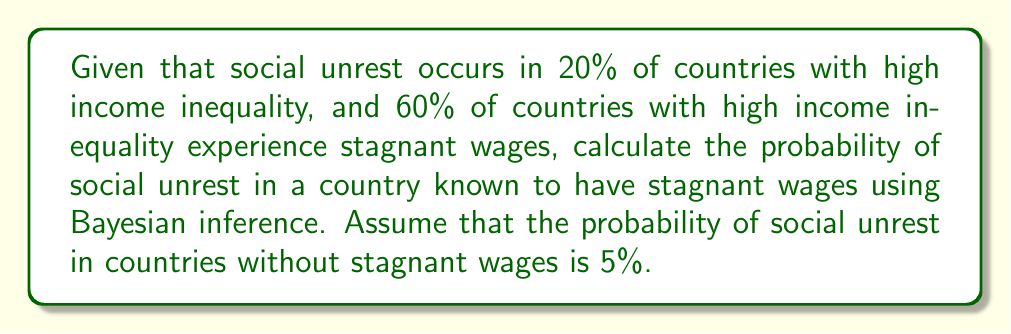Could you help me with this problem? Let's approach this step-by-step using Bayesian inference:

1) Define our events:
   A: Social unrest occurs
   B: Country has stagnant wages

2) Given probabilities:
   P(A) = 0.20 (probability of social unrest in countries with high income inequality)
   P(B) = 0.60 (probability of stagnant wages in countries with high income inequality)
   P(A|not B) = 0.05 (probability of social unrest in countries without stagnant wages)

3) We need to find P(A|B) using Bayes' theorem:

   $$P(A|B) = \frac{P(B|A) \cdot P(A)}{P(B)}$$

4) We need to calculate P(B|A):
   Using the law of total probability:
   
   $$P(A) = P(A|B) \cdot P(B) + P(A|not B) \cdot P(not B)$$
   
   $$0.20 = P(A|B) \cdot 0.60 + 0.05 \cdot 0.40$$
   
   $$0.20 = 0.60P(A|B) + 0.02$$
   
   $$0.18 = 0.60P(A|B)$$
   
   $$P(A|B) = 0.30$$

5) Now we can calculate P(B|A):
   
   $$P(B|A) = \frac{P(A|B) \cdot P(B)}{P(A)} = \frac{0.30 \cdot 0.60}{0.20} = 0.90$$

6) Finally, we can use Bayes' theorem:

   $$P(A|B) = \frac{P(B|A) \cdot P(A)}{P(B)} = \frac{0.90 \cdot 0.20}{0.60} = 0.30$$

Thus, the probability of social unrest in a country known to have stagnant wages is 0.30 or 30%.
Answer: 0.30 